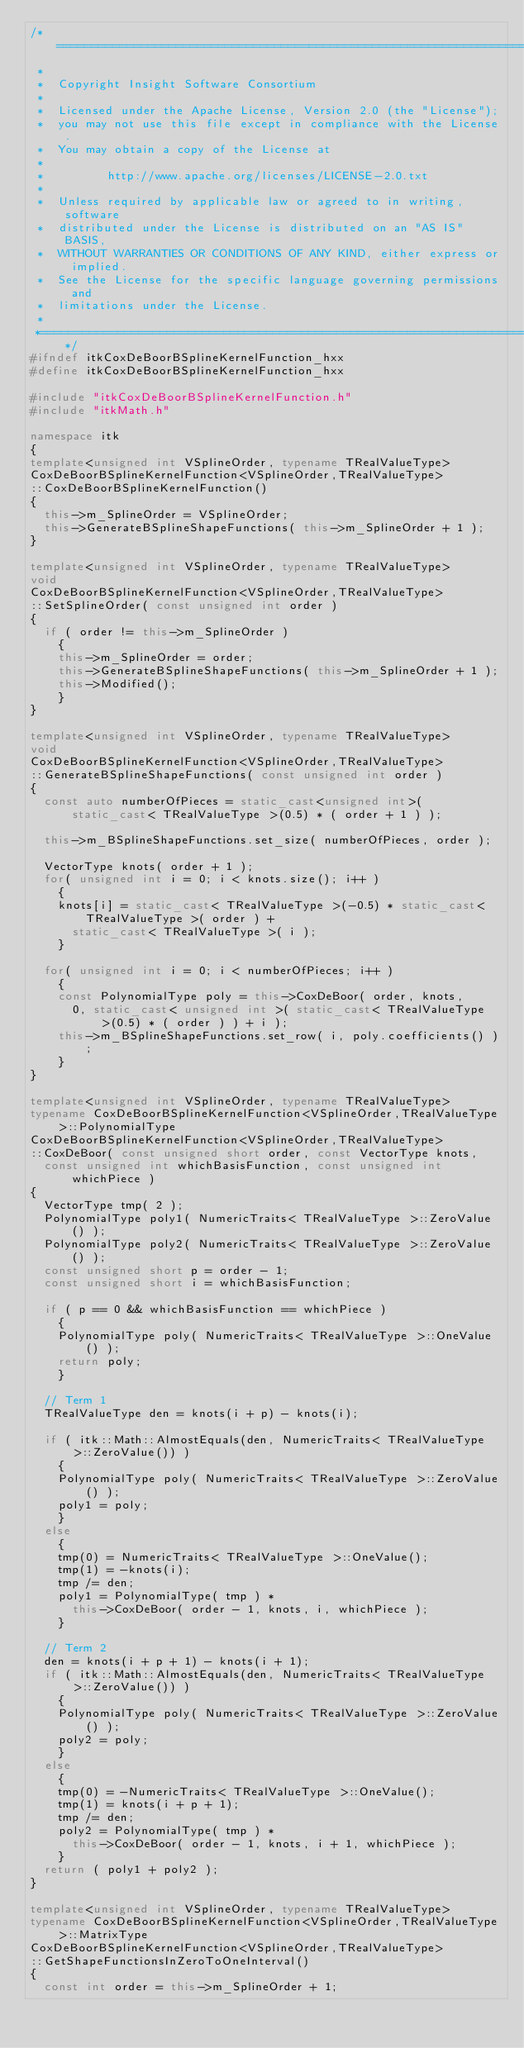Convert code to text. <code><loc_0><loc_0><loc_500><loc_500><_C++_>/*=========================================================================
 *
 *  Copyright Insight Software Consortium
 *
 *  Licensed under the Apache License, Version 2.0 (the "License");
 *  you may not use this file except in compliance with the License.
 *  You may obtain a copy of the License at
 *
 *         http://www.apache.org/licenses/LICENSE-2.0.txt
 *
 *  Unless required by applicable law or agreed to in writing, software
 *  distributed under the License is distributed on an "AS IS" BASIS,
 *  WITHOUT WARRANTIES OR CONDITIONS OF ANY KIND, either express or implied.
 *  See the License for the specific language governing permissions and
 *  limitations under the License.
 *
 *=========================================================================*/
#ifndef itkCoxDeBoorBSplineKernelFunction_hxx
#define itkCoxDeBoorBSplineKernelFunction_hxx

#include "itkCoxDeBoorBSplineKernelFunction.h"
#include "itkMath.h"

namespace itk
{
template<unsigned int VSplineOrder, typename TRealValueType>
CoxDeBoorBSplineKernelFunction<VSplineOrder,TRealValueType>
::CoxDeBoorBSplineKernelFunction()
{
  this->m_SplineOrder = VSplineOrder;
  this->GenerateBSplineShapeFunctions( this->m_SplineOrder + 1 );
}

template<unsigned int VSplineOrder, typename TRealValueType>
void
CoxDeBoorBSplineKernelFunction<VSplineOrder,TRealValueType>
::SetSplineOrder( const unsigned int order )
{
  if ( order != this->m_SplineOrder )
    {
    this->m_SplineOrder = order;
    this->GenerateBSplineShapeFunctions( this->m_SplineOrder + 1 );
    this->Modified();
    }
}

template<unsigned int VSplineOrder, typename TRealValueType>
void
CoxDeBoorBSplineKernelFunction<VSplineOrder,TRealValueType>
::GenerateBSplineShapeFunctions( const unsigned int order )
{
  const auto numberOfPieces = static_cast<unsigned int>( static_cast< TRealValueType >(0.5) * ( order + 1 ) );

  this->m_BSplineShapeFunctions.set_size( numberOfPieces, order );

  VectorType knots( order + 1 );
  for( unsigned int i = 0; i < knots.size(); i++ )
    {
    knots[i] = static_cast< TRealValueType >(-0.5) * static_cast< TRealValueType >( order ) +
      static_cast< TRealValueType >( i );
    }

  for( unsigned int i = 0; i < numberOfPieces; i++ )
    {
    const PolynomialType poly = this->CoxDeBoor( order, knots,
      0, static_cast< unsigned int >( static_cast< TRealValueType >(0.5) * ( order ) ) + i );
    this->m_BSplineShapeFunctions.set_row( i, poly.coefficients() );
    }
}

template<unsigned int VSplineOrder, typename TRealValueType>
typename CoxDeBoorBSplineKernelFunction<VSplineOrder,TRealValueType>::PolynomialType
CoxDeBoorBSplineKernelFunction<VSplineOrder,TRealValueType>
::CoxDeBoor( const unsigned short order, const VectorType knots,
  const unsigned int whichBasisFunction, const unsigned int whichPiece )
{
  VectorType tmp( 2 );
  PolynomialType poly1( NumericTraits< TRealValueType >::ZeroValue() );
  PolynomialType poly2( NumericTraits< TRealValueType >::ZeroValue() );
  const unsigned short p = order - 1;
  const unsigned short i = whichBasisFunction;

  if ( p == 0 && whichBasisFunction == whichPiece )
    {
    PolynomialType poly( NumericTraits< TRealValueType >::OneValue() );
    return poly;
    }

  // Term 1
  TRealValueType den = knots(i + p) - knots(i);

  if ( itk::Math::AlmostEquals(den, NumericTraits< TRealValueType >::ZeroValue()) )
    {
    PolynomialType poly( NumericTraits< TRealValueType >::ZeroValue() );
    poly1 = poly;
    }
  else
    {
    tmp(0) = NumericTraits< TRealValueType >::OneValue();
    tmp(1) = -knots(i);
    tmp /= den;
    poly1 = PolynomialType( tmp ) *
      this->CoxDeBoor( order - 1, knots, i, whichPiece );
    }

  // Term 2
  den = knots(i + p + 1) - knots(i + 1);
  if ( itk::Math::AlmostEquals(den, NumericTraits< TRealValueType >::ZeroValue()) )
    {
    PolynomialType poly( NumericTraits< TRealValueType >::ZeroValue() );
    poly2 = poly;
    }
  else
    {
    tmp(0) = -NumericTraits< TRealValueType >::OneValue();
    tmp(1) = knots(i + p + 1);
    tmp /= den;
    poly2 = PolynomialType( tmp ) *
      this->CoxDeBoor( order - 1, knots, i + 1, whichPiece );
    }
  return ( poly1 + poly2 );
}

template<unsigned int VSplineOrder, typename TRealValueType>
typename CoxDeBoorBSplineKernelFunction<VSplineOrder,TRealValueType>::MatrixType
CoxDeBoorBSplineKernelFunction<VSplineOrder,TRealValueType>
::GetShapeFunctionsInZeroToOneInterval()
{
  const int order = this->m_SplineOrder + 1;</code> 